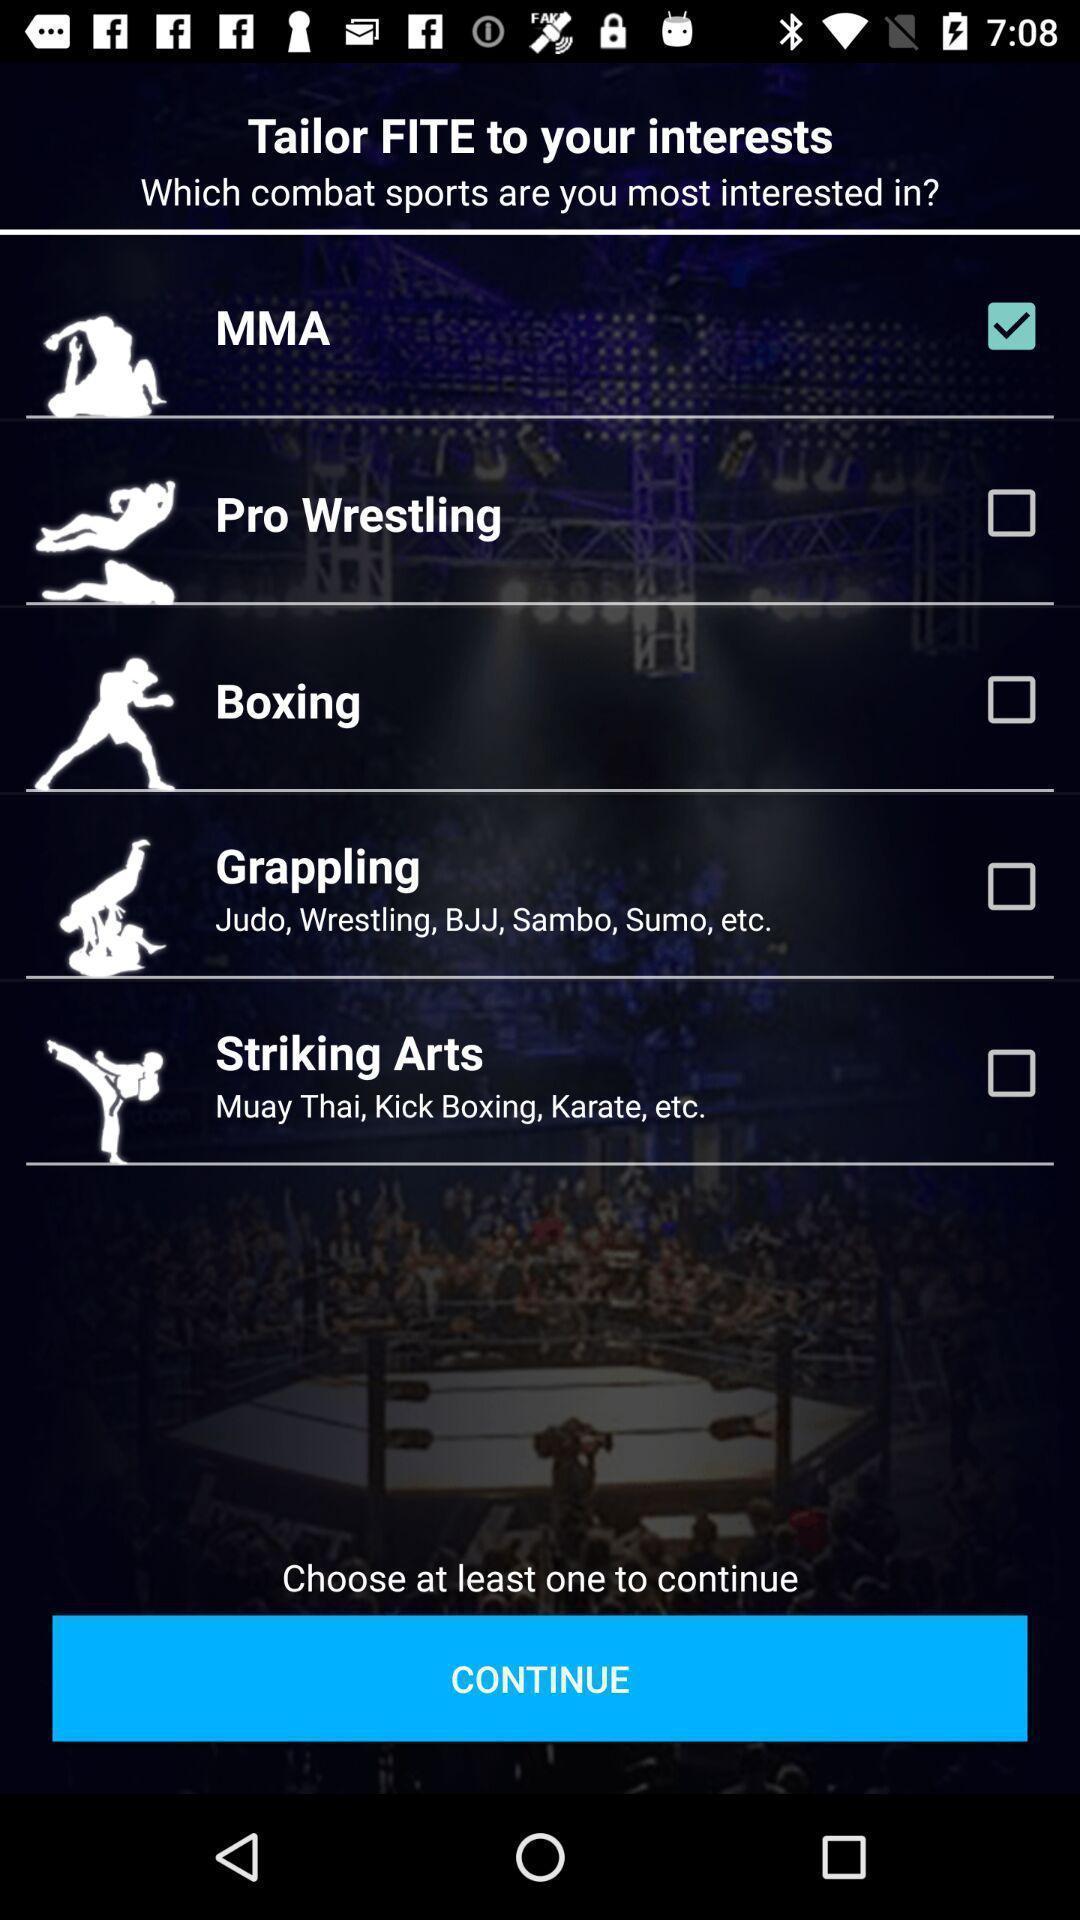Tell me about the visual elements in this screen capture. Page showing option like continue. 